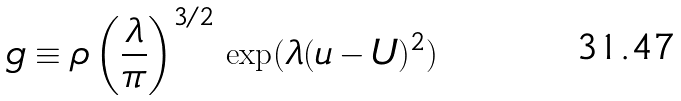<formula> <loc_0><loc_0><loc_500><loc_500>g \equiv \rho \left ( \frac { \lambda } { \pi } \right ) ^ { 3 / 2 } \, \exp ( \lambda ( u - U ) ^ { 2 } )</formula> 